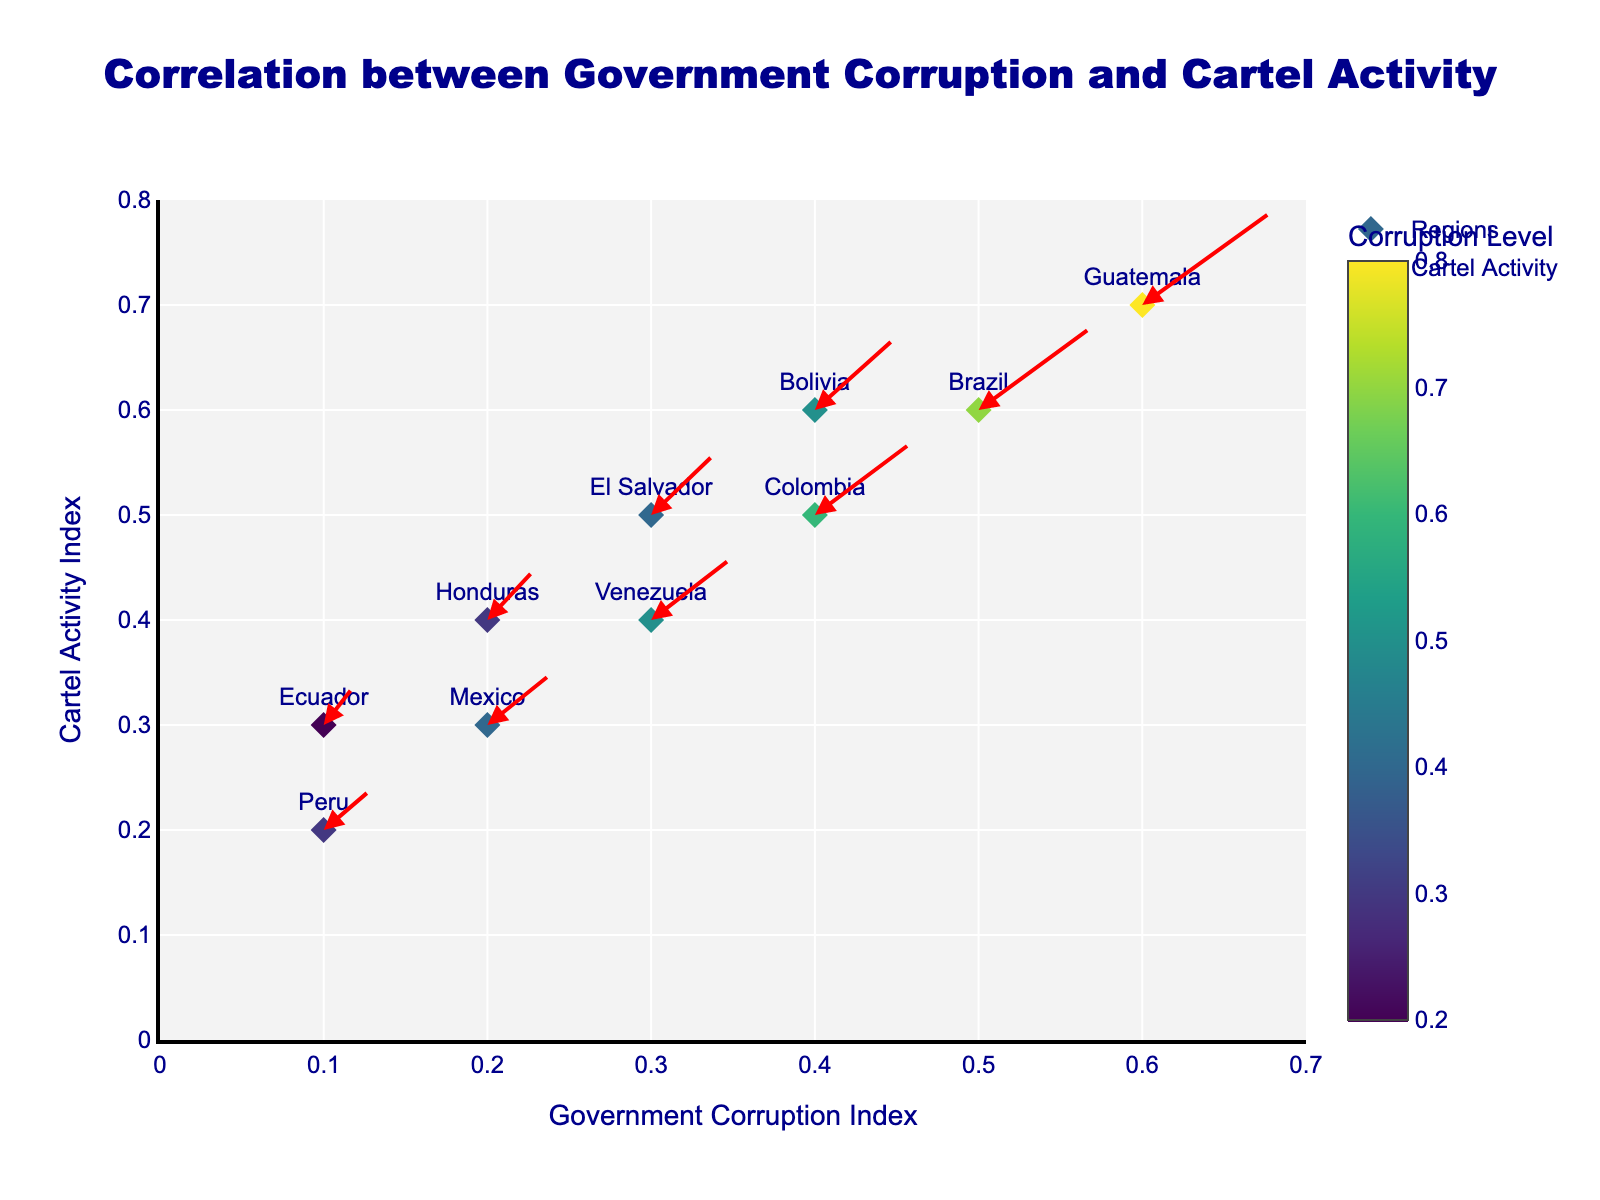What does the plot title state? The plot title is prominently placed at the top of the figure and is written in a larger font for clarity.
Answer: Correlation between Government Corruption and Cartel Activity What region corresponds to the highest corruption level in the plot? The region with the highest corruption level will have the highest 'u' value in the marker. The color bar indicates the corruption levels, and Guatemala shows the highest value near the top of the color scale.
Answer: Guatemala Which region shows the smallest movement in cartel activity? To find the smallest movement, look for the region with the smallest arrow values (u and v). Ecuador has the smallest values (u=0.2 and v=0.4), indicating the least movement in the plot.
Answer: Ecuador How do the corruption levels and cartel activity levels of Honduras compare to those of Venezuela? Compare the 'u' and 'v' values of both regions. For Honduras, u=0.3 and v=0.5. For Venezuela, u=0.5 and v=0.6. Thus, Venezuela has slightly higher values in both metrics than Honduras.
Answer: Venezuela has higher corruption and cartel activity levels What general trend can be observed between government corruption and cartel activity across the regions? Observe the directions and lengths of the arrows representing each region. Regions with higher corruption indices (higher u values) generally correlate with higher cartel activity (higher v values), indicated by the length and direction of the arrows.
Answer: Higher corruption generally correlates with higher cartel activity In which direction does cartel activity increase for Mexico? The direction of the arrow for Mexico indicates the movement in cartel activity. It points to the right and upwards, indicating an increase in both x and y directions.
Answer: Right and upwards Which regions show a significant increase in both corruption and cartel activities? Look at the length of the arrows for the regions. Guatemala and Brazil have visibly longer arrows, indicating significant increases in both corruption and cartel activities.
Answer: Guatemala and Brazil Which pair of regions have nearly parallel arrows, indicating similar directional changes in cartel activity? Identify the arrows with similar directions. Mexico and Honduras have arrows pointing in similar directions, indicating that the changes in cartel activity for these regions were similar in both magnitude and direction.
Answer: Mexico and Honduras What is the range of the Government Corruption Index displayed on the x-axis? The x-axis is labeled "Government Corruption Index," and the range can be read off the axis marks. The plot shows a range between 0 and 0.7.
Answer: 0 to 0.7 